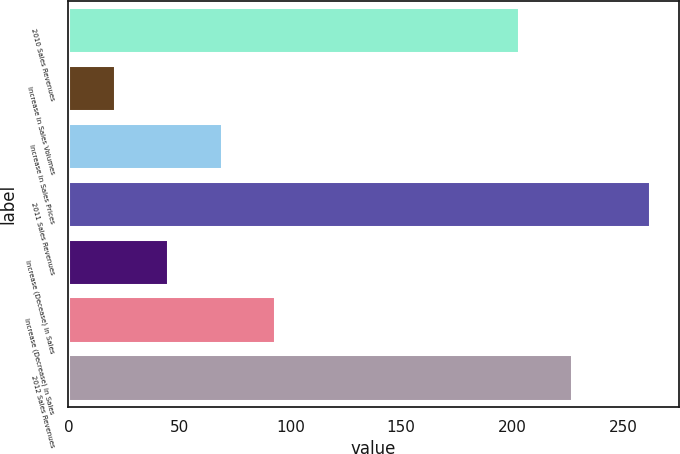Convert chart. <chart><loc_0><loc_0><loc_500><loc_500><bar_chart><fcel>2010 Sales Revenues<fcel>Increase in Sales Volumes<fcel>Increase in Sales Prices<fcel>2011 Sales Revenues<fcel>Increase (Decease) in Sales<fcel>Increase (Decrease) in Sales<fcel>2012 Sales Revenues<nl><fcel>203<fcel>21<fcel>69.2<fcel>262<fcel>45.1<fcel>93.3<fcel>227.1<nl></chart> 